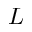<formula> <loc_0><loc_0><loc_500><loc_500>L</formula> 